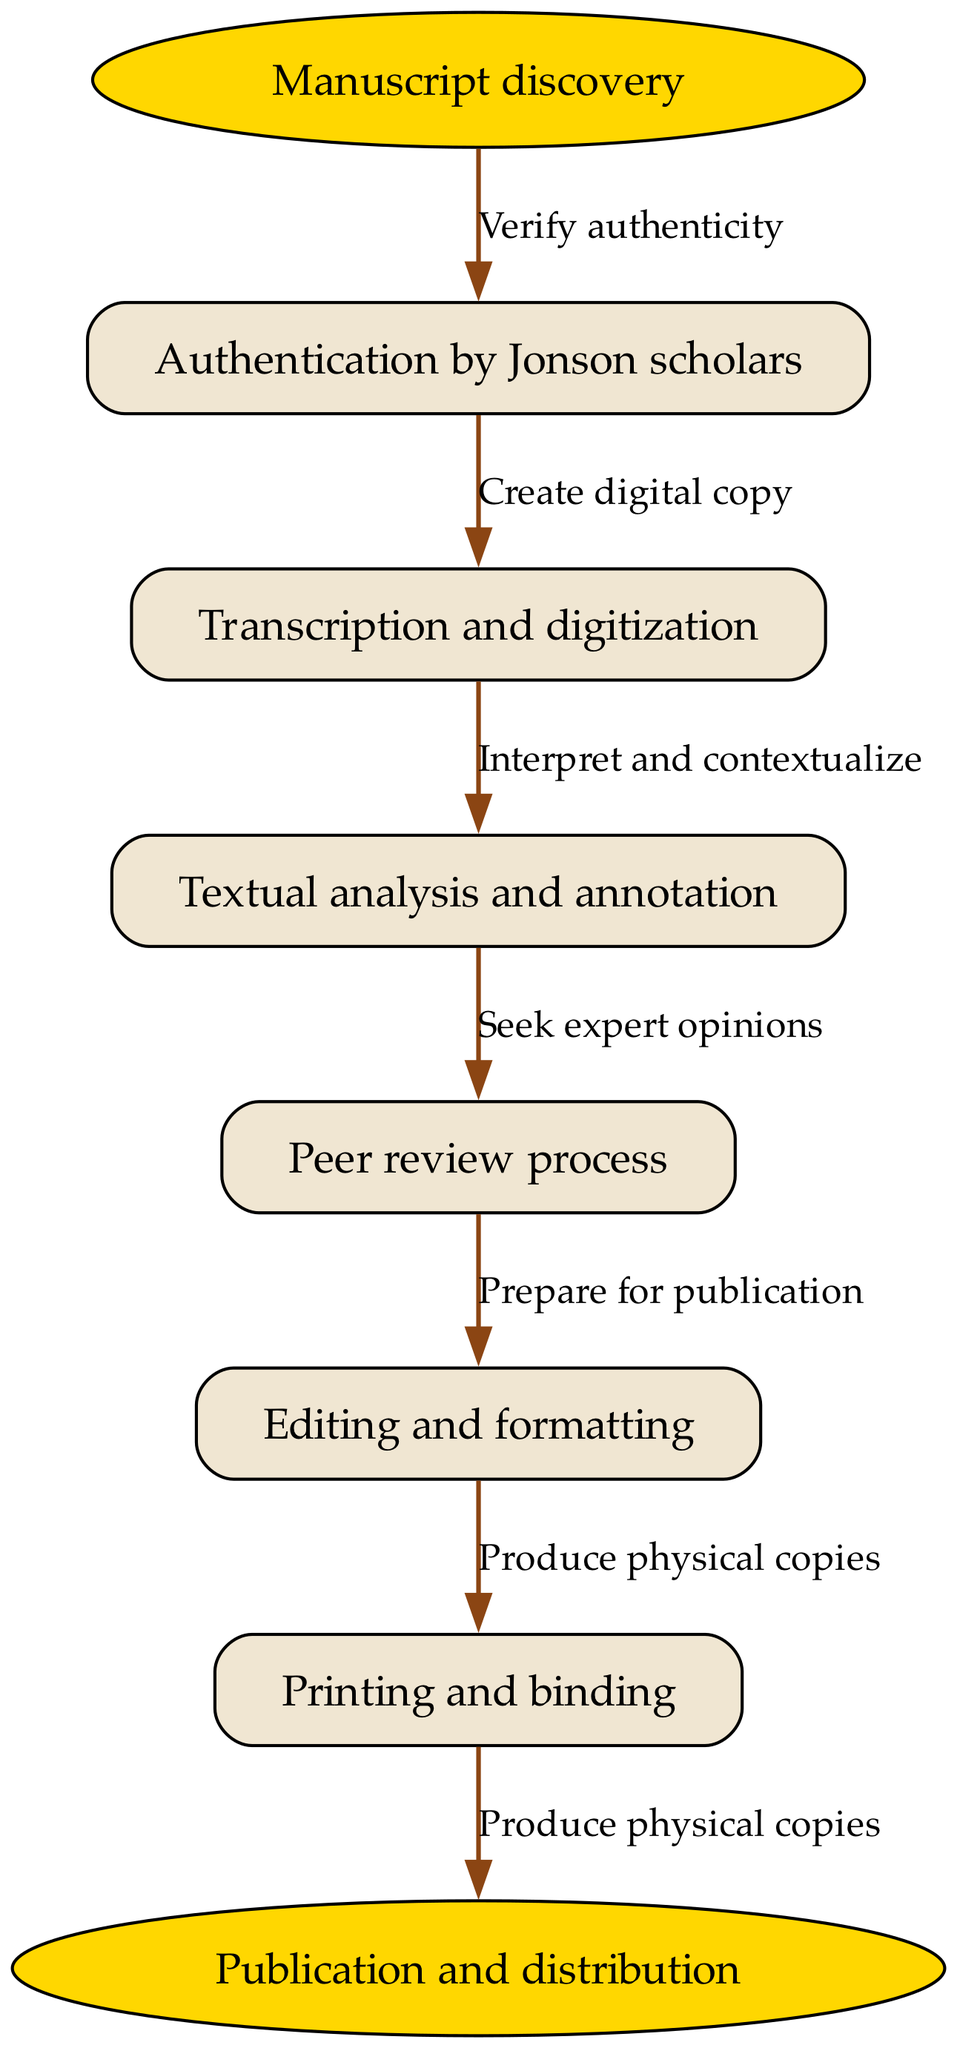What is the starting point of the diagram? The starting point of the diagram is labeled "Manuscript discovery," which serves as the initial step in the journey of a Ben Jonson manuscript.
Answer: Manuscript discovery What is the last step before publication? The last step before reaching the final endpoint, "Publication and distribution," is "Printing and binding." This indicates that the manuscript is prepared for physical distribution at this stage.
Answer: Printing and binding How many nodes are in the diagram? The diagram contains a total of six nodes, counting both the starting point and the endpoints along with the intermediate steps involved in the manuscript's journey.
Answer: Six What is the edge connecting "Transcription and digitization" to the next node? The edge connecting "Transcription and digitization" to the following node is labeled "Create digital copy," indicating the action taken after this step.
Answer: Create digital copy Which node comes right after "Textual analysis and annotation"? The node that comes immediately after "Textual analysis and annotation" is "Peer review process." This indicates the subsequent stage in the manuscript's journey after textual analysis.
Answer: Peer review process What is the relationship between "Authentication by Jonson scholars" and "Transcription and digitization"? The relationship is that "Authentication by Jonson scholars" is the first step, leading directly to "Transcription and digitization," indicating that verification of authenticity is necessary before digitization can take place.
Answer: Verify authenticity What action is necessary for "Editing and formatting"? The necessary action for "Editing and formatting" is "Prepare for publication," which implies that editing and formatting is an essential step to finalize the manuscript before it can be published.
Answer: Prepare for publication What is the function of the edges in this diagram? The edges in the diagram represent the actions or processes that connect one node to another, illustrating the sequence of steps involved in transforming a manuscript from initial discovery to final publication.
Answer: Represent actions What step is similar to "Peer review process" in terms of critical evaluation? "Textual analysis and annotation" serves a similar function to the "Peer review process," as both involve critical evaluation and interpretation of the manuscript's content for improved understanding.
Answer: Textual analysis and annotation 